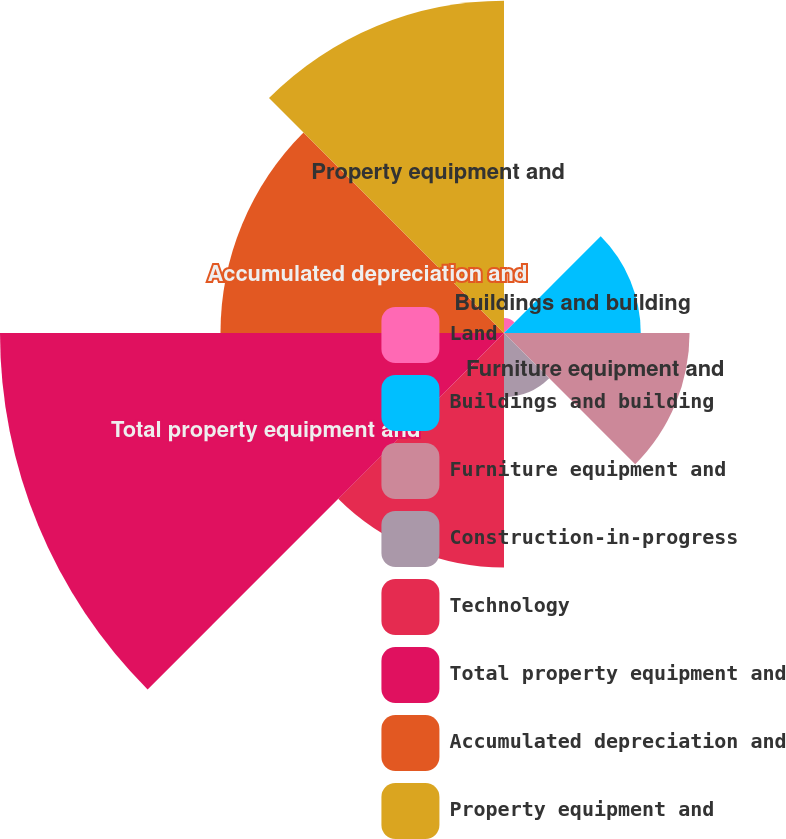Convert chart. <chart><loc_0><loc_0><loc_500><loc_500><pie_chart><fcel>Land<fcel>Buildings and building<fcel>Furniture equipment and<fcel>Construction-in-progress<fcel>Technology<fcel>Total property equipment and<fcel>Accumulated depreciation and<fcel>Property equipment and<nl><fcel>0.85%<fcel>7.79%<fcel>10.57%<fcel>3.64%<fcel>13.36%<fcel>28.71%<fcel>16.15%<fcel>18.93%<nl></chart> 